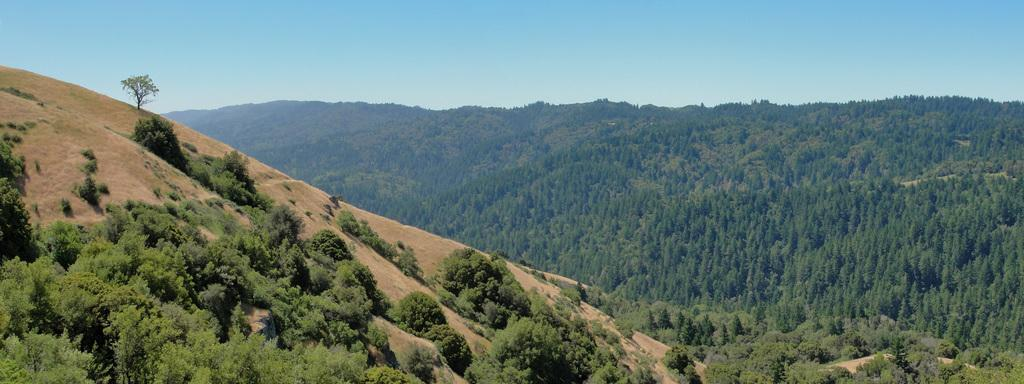What type of vegetation can be seen in the image? There are trees in the image. What is visible at the top of the image? The sky is visible at the top of the image. What type of bean is growing on the trees in the image? There are no beans present in the image; it features trees and a visible sky. How does the wave affect the trees in the image? There is no wave present in the image; it only shows trees and the sky. 